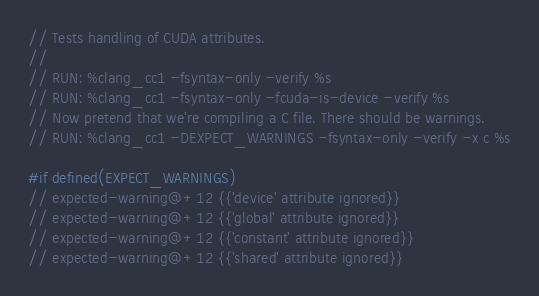Convert code to text. <code><loc_0><loc_0><loc_500><loc_500><_Cuda_>// Tests handling of CUDA attributes.
//
// RUN: %clang_cc1 -fsyntax-only -verify %s
// RUN: %clang_cc1 -fsyntax-only -fcuda-is-device -verify %s
// Now pretend that we're compiling a C file. There should be warnings.
// RUN: %clang_cc1 -DEXPECT_WARNINGS -fsyntax-only -verify -x c %s

#if defined(EXPECT_WARNINGS)
// expected-warning@+12 {{'device' attribute ignored}}
// expected-warning@+12 {{'global' attribute ignored}}
// expected-warning@+12 {{'constant' attribute ignored}}
// expected-warning@+12 {{'shared' attribute ignored}}</code> 